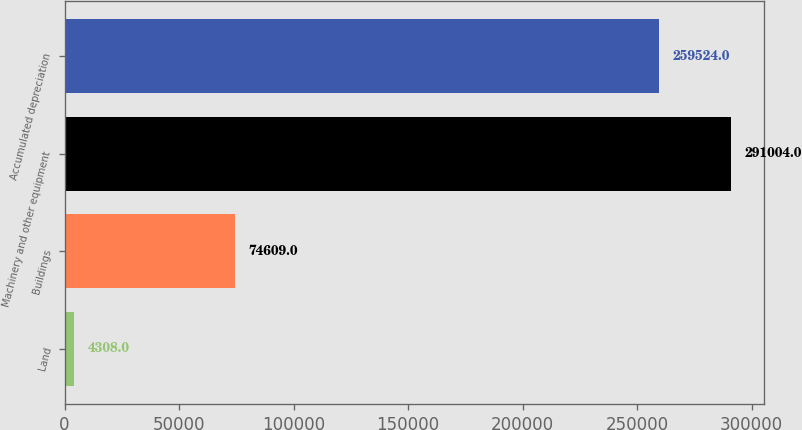Convert chart to OTSL. <chart><loc_0><loc_0><loc_500><loc_500><bar_chart><fcel>Land<fcel>Buildings<fcel>Machinery and other equipment<fcel>Accumulated depreciation<nl><fcel>4308<fcel>74609<fcel>291004<fcel>259524<nl></chart> 